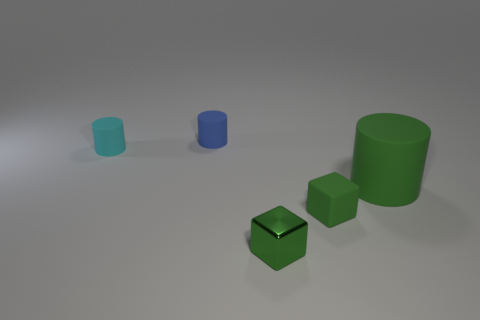The shiny object that is the same color as the big matte object is what size?
Ensure brevity in your answer.  Small. What is the material of the large object that is the same color as the rubber cube?
Provide a short and direct response. Rubber. Is the size of the cyan rubber cylinder that is left of the blue cylinder the same as the small rubber block?
Offer a terse response. Yes. Is there anything else that is the same size as the green matte cylinder?
Keep it short and to the point. No. Is the number of matte objects that are in front of the tiny blue cylinder greater than the number of green cylinders in front of the green shiny object?
Offer a very short reply. Yes. The matte object that is in front of the big green cylinder that is behind the rubber object in front of the green rubber cylinder is what color?
Your answer should be very brief. Green. There is a small rubber object right of the small blue rubber cylinder; is it the same color as the big thing?
Your answer should be very brief. Yes. What number of other things are there of the same color as the metal thing?
Ensure brevity in your answer.  2. How many things are either cyan cylinders or brown matte cylinders?
Give a very brief answer. 1. How many objects are either small cyan metallic cylinders or small green objects in front of the tiny green matte object?
Ensure brevity in your answer.  1. 